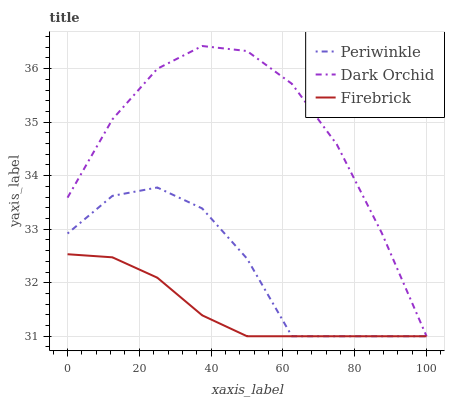Does Periwinkle have the minimum area under the curve?
Answer yes or no. No. Does Periwinkle have the maximum area under the curve?
Answer yes or no. No. Is Dark Orchid the smoothest?
Answer yes or no. No. Is Dark Orchid the roughest?
Answer yes or no. No. Does Periwinkle have the highest value?
Answer yes or no. No. 